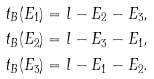Convert formula to latex. <formula><loc_0><loc_0><loc_500><loc_500>\ t _ { B } ( E _ { 1 } ) & = l - E _ { 2 } - E _ { 3 } , \\ \ t _ { B } ( E _ { 2 } ) & = l - E _ { 3 } - E _ { 1 } , \\ \ t _ { B } ( E _ { 3 } ) & = l - E _ { 1 } - E _ { 2 } .</formula> 